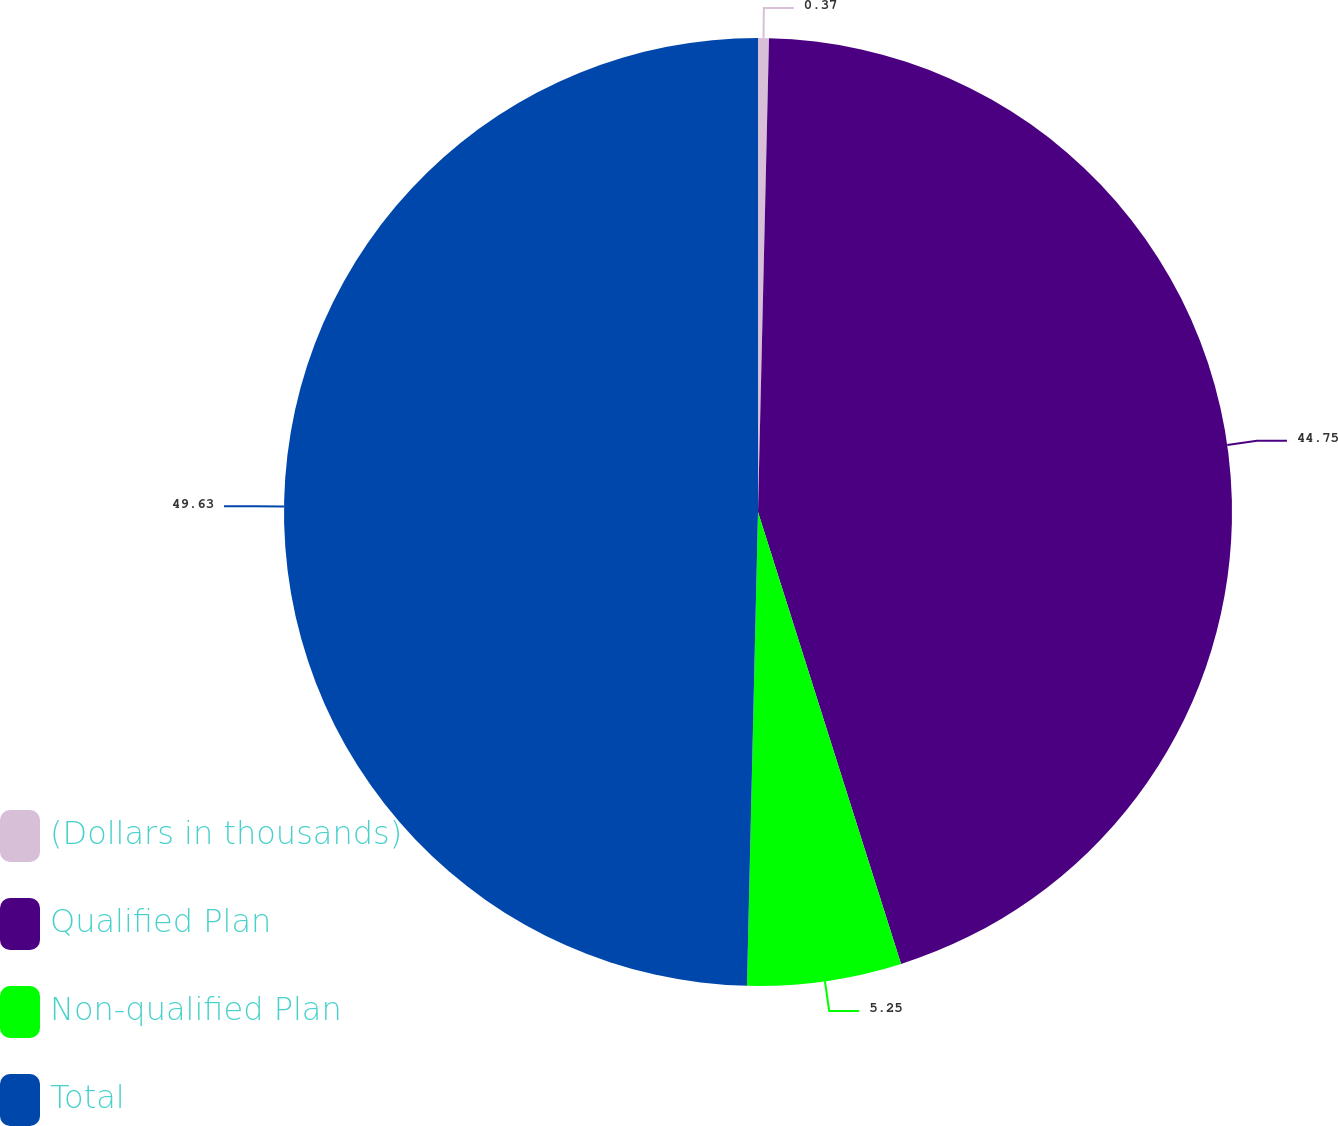<chart> <loc_0><loc_0><loc_500><loc_500><pie_chart><fcel>(Dollars in thousands)<fcel>Qualified Plan<fcel>Non-qualified Plan<fcel>Total<nl><fcel>0.37%<fcel>44.75%<fcel>5.25%<fcel>49.63%<nl></chart> 